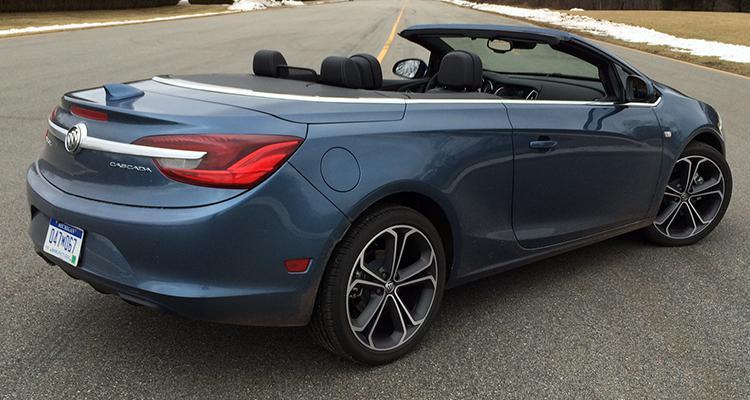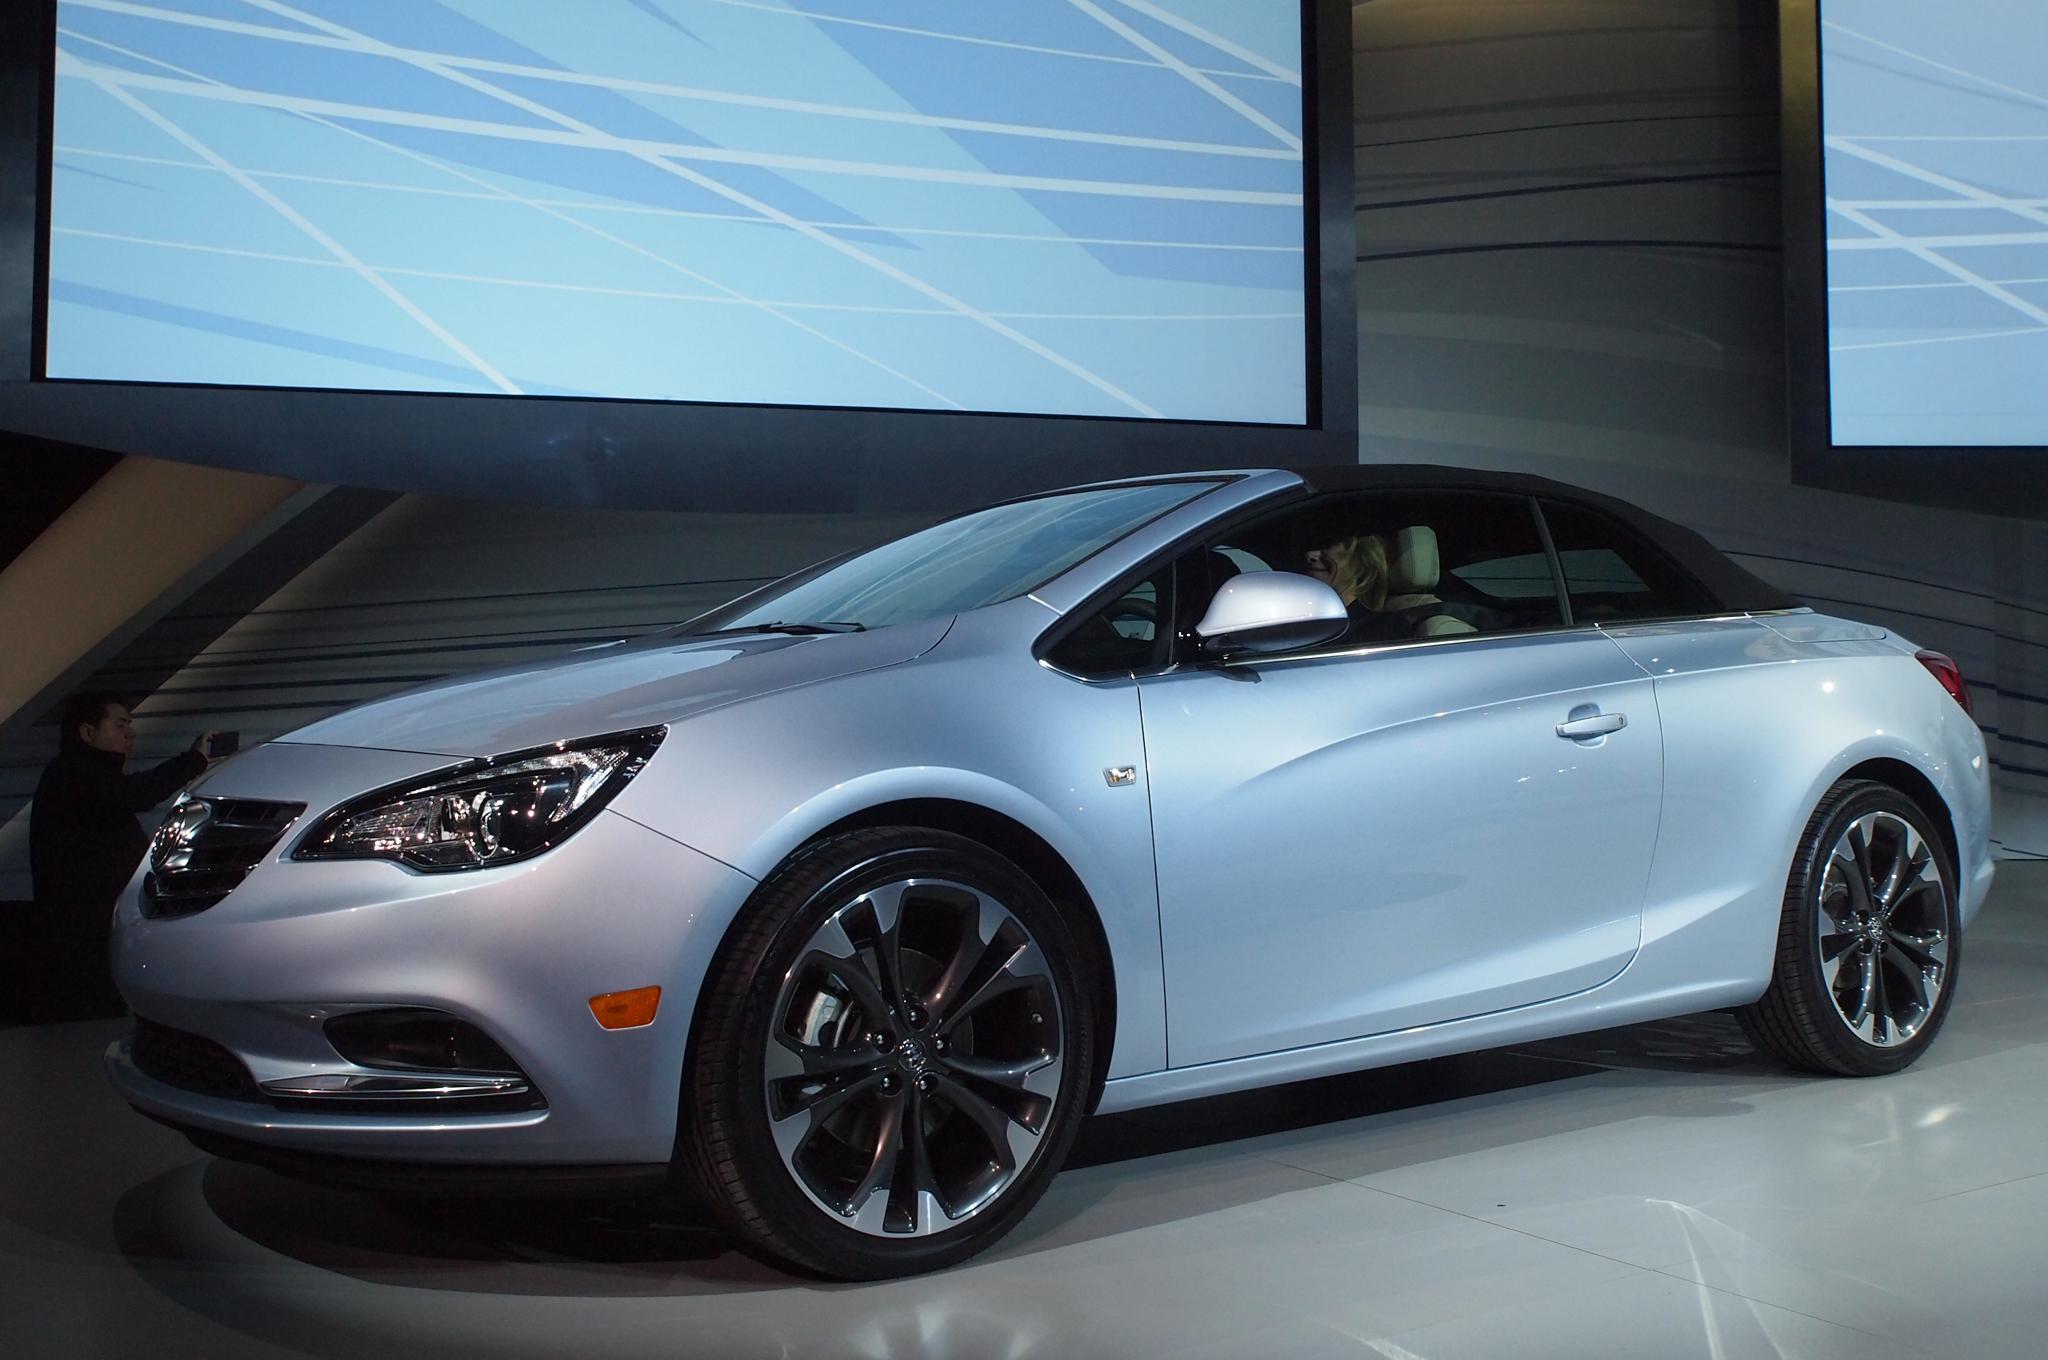The first image is the image on the left, the second image is the image on the right. For the images shown, is this caption "The left image contains a convertible that is facing towards the left." true? Answer yes or no. No. 